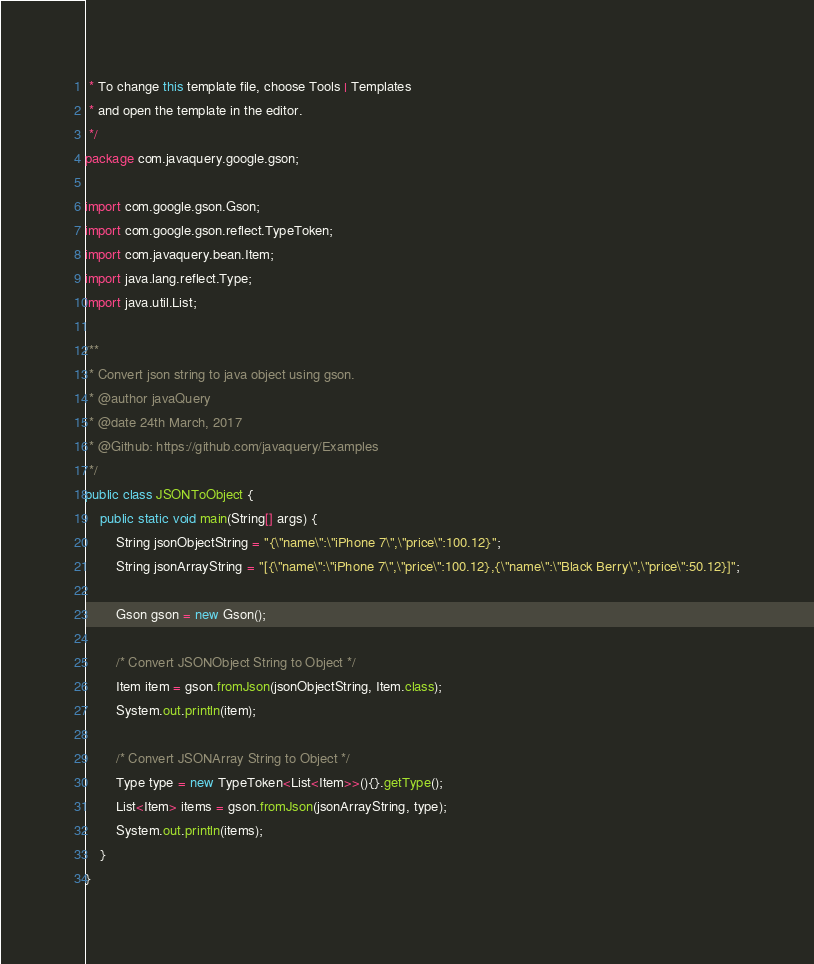<code> <loc_0><loc_0><loc_500><loc_500><_Java_> * To change this template file, choose Tools | Templates
 * and open the template in the editor.
 */
package com.javaquery.google.gson;

import com.google.gson.Gson;
import com.google.gson.reflect.TypeToken;
import com.javaquery.bean.Item;
import java.lang.reflect.Type;
import java.util.List;

/**
 * Convert json string to java object using gson.
 * @author javaQuery
 * @date 24th March, 2017
 * @Github: https://github.com/javaquery/Examples
 */
public class JSONToObject {
    public static void main(String[] args) {
        String jsonObjectString = "{\"name\":\"iPhone 7\",\"price\":100.12}";
        String jsonArrayString = "[{\"name\":\"iPhone 7\",\"price\":100.12},{\"name\":\"Black Berry\",\"price\":50.12}]";
        
        Gson gson = new Gson();
        
        /* Convert JSONObject String to Object */
        Item item = gson.fromJson(jsonObjectString, Item.class);
        System.out.println(item);
        
        /* Convert JSONArray String to Object */
        Type type = new TypeToken<List<Item>>(){}.getType();
        List<Item> items = gson.fromJson(jsonArrayString, type);
        System.out.println(items);
    }
}
</code> 